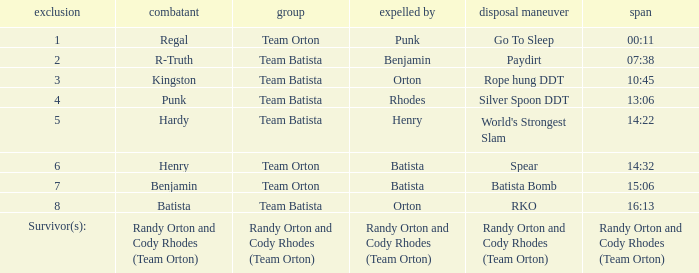Help me parse the entirety of this table. {'header': ['exclusion', 'combatant', 'group', 'expelled by', 'disposal maneuver', 'span'], 'rows': [['1', 'Regal', 'Team Orton', 'Punk', 'Go To Sleep', '00:11'], ['2', 'R-Truth', 'Team Batista', 'Benjamin', 'Paydirt', '07:38'], ['3', 'Kingston', 'Team Batista', 'Orton', 'Rope hung DDT', '10:45'], ['4', 'Punk', 'Team Batista', 'Rhodes', 'Silver Spoon DDT', '13:06'], ['5', 'Hardy', 'Team Batista', 'Henry', "World's Strongest Slam", '14:22'], ['6', 'Henry', 'Team Orton', 'Batista', 'Spear', '14:32'], ['7', 'Benjamin', 'Team Orton', 'Batista', 'Batista Bomb', '15:06'], ['8', 'Batista', 'Team Batista', 'Orton', 'RKO', '16:13'], ['Survivor(s):', 'Randy Orton and Cody Rhodes (Team Orton)', 'Randy Orton and Cody Rhodes (Team Orton)', 'Randy Orton and Cody Rhodes (Team Orton)', 'Randy Orton and Cody Rhodes (Team Orton)', 'Randy Orton and Cody Rhodes (Team Orton)']]} Which Elimination Move is listed at Elimination 8 for Team Batista? RKO. 